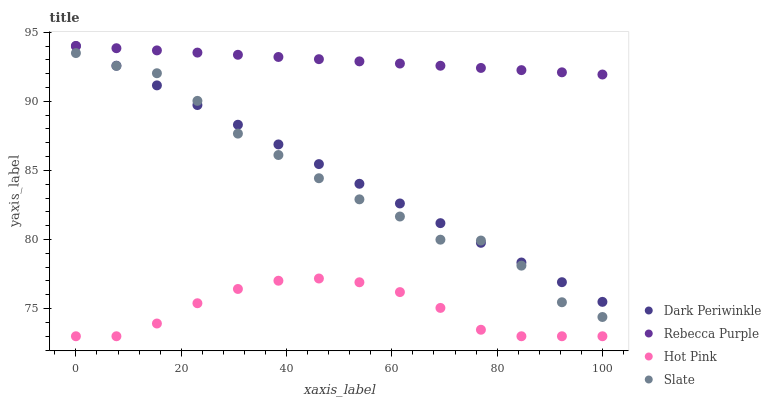Does Hot Pink have the minimum area under the curve?
Answer yes or no. Yes. Does Rebecca Purple have the maximum area under the curve?
Answer yes or no. Yes. Does Dark Periwinkle have the minimum area under the curve?
Answer yes or no. No. Does Dark Periwinkle have the maximum area under the curve?
Answer yes or no. No. Is Rebecca Purple the smoothest?
Answer yes or no. Yes. Is Slate the roughest?
Answer yes or no. Yes. Is Hot Pink the smoothest?
Answer yes or no. No. Is Hot Pink the roughest?
Answer yes or no. No. Does Hot Pink have the lowest value?
Answer yes or no. Yes. Does Dark Periwinkle have the lowest value?
Answer yes or no. No. Does Rebecca Purple have the highest value?
Answer yes or no. Yes. Does Hot Pink have the highest value?
Answer yes or no. No. Is Hot Pink less than Rebecca Purple?
Answer yes or no. Yes. Is Rebecca Purple greater than Slate?
Answer yes or no. Yes. Does Dark Periwinkle intersect Rebecca Purple?
Answer yes or no. Yes. Is Dark Periwinkle less than Rebecca Purple?
Answer yes or no. No. Is Dark Periwinkle greater than Rebecca Purple?
Answer yes or no. No. Does Hot Pink intersect Rebecca Purple?
Answer yes or no. No. 